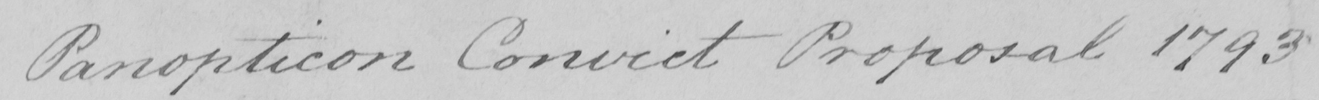Can you read and transcribe this handwriting? Panopticon Convict Proposal 1793 